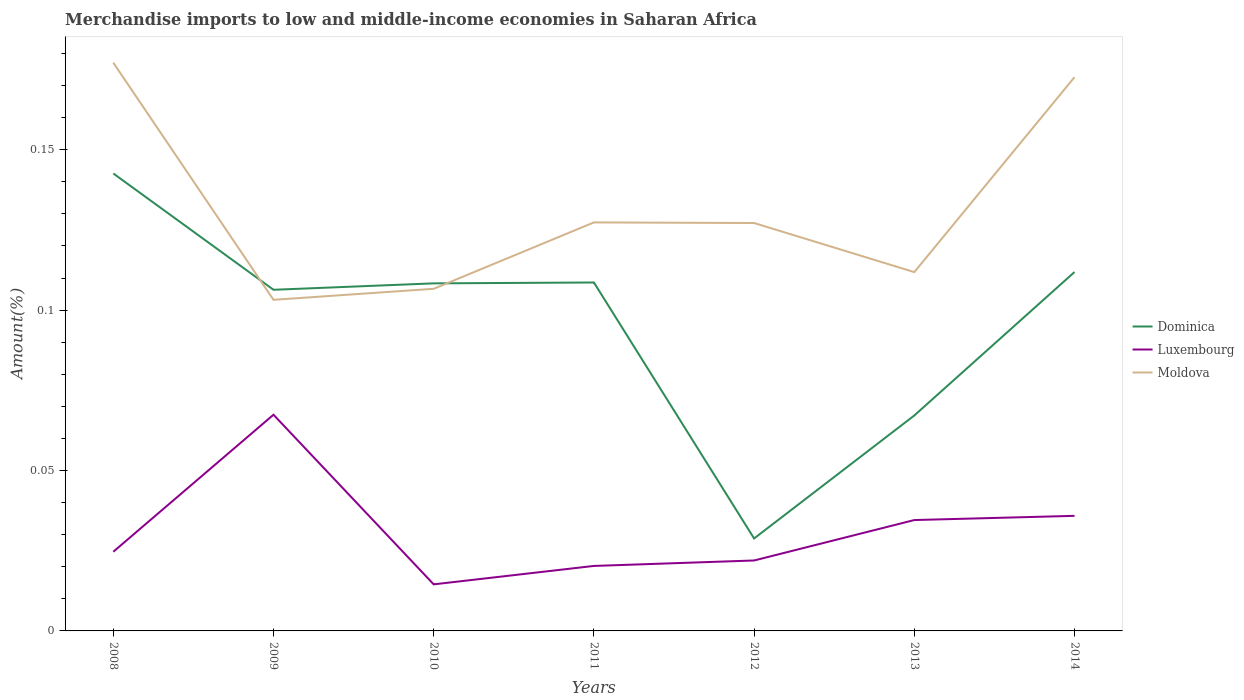How many different coloured lines are there?
Make the answer very short. 3. Across all years, what is the maximum percentage of amount earned from merchandise imports in Luxembourg?
Make the answer very short. 0.01. In which year was the percentage of amount earned from merchandise imports in Moldova maximum?
Your response must be concise. 2009. What is the total percentage of amount earned from merchandise imports in Luxembourg in the graph?
Provide a succinct answer. 0.05. What is the difference between the highest and the second highest percentage of amount earned from merchandise imports in Dominica?
Your answer should be compact. 0.11. What is the difference between the highest and the lowest percentage of amount earned from merchandise imports in Luxembourg?
Offer a terse response. 3. How many years are there in the graph?
Give a very brief answer. 7. Are the values on the major ticks of Y-axis written in scientific E-notation?
Keep it short and to the point. No. Does the graph contain any zero values?
Keep it short and to the point. No. How many legend labels are there?
Your answer should be compact. 3. How are the legend labels stacked?
Provide a succinct answer. Vertical. What is the title of the graph?
Keep it short and to the point. Merchandise imports to low and middle-income economies in Saharan Africa. What is the label or title of the Y-axis?
Offer a very short reply. Amount(%). What is the Amount(%) of Dominica in 2008?
Ensure brevity in your answer.  0.14. What is the Amount(%) in Luxembourg in 2008?
Provide a succinct answer. 0.02. What is the Amount(%) of Moldova in 2008?
Make the answer very short. 0.18. What is the Amount(%) in Dominica in 2009?
Your answer should be very brief. 0.11. What is the Amount(%) in Luxembourg in 2009?
Make the answer very short. 0.07. What is the Amount(%) of Moldova in 2009?
Your answer should be very brief. 0.1. What is the Amount(%) in Dominica in 2010?
Offer a very short reply. 0.11. What is the Amount(%) of Luxembourg in 2010?
Keep it short and to the point. 0.01. What is the Amount(%) in Moldova in 2010?
Your response must be concise. 0.11. What is the Amount(%) in Dominica in 2011?
Your answer should be very brief. 0.11. What is the Amount(%) in Luxembourg in 2011?
Your response must be concise. 0.02. What is the Amount(%) in Moldova in 2011?
Offer a very short reply. 0.13. What is the Amount(%) of Dominica in 2012?
Ensure brevity in your answer.  0.03. What is the Amount(%) in Luxembourg in 2012?
Provide a short and direct response. 0.02. What is the Amount(%) in Moldova in 2012?
Provide a succinct answer. 0.13. What is the Amount(%) of Dominica in 2013?
Your response must be concise. 0.07. What is the Amount(%) of Luxembourg in 2013?
Your answer should be compact. 0.03. What is the Amount(%) in Moldova in 2013?
Offer a terse response. 0.11. What is the Amount(%) of Dominica in 2014?
Provide a short and direct response. 0.11. What is the Amount(%) in Luxembourg in 2014?
Your response must be concise. 0.04. What is the Amount(%) of Moldova in 2014?
Give a very brief answer. 0.17. Across all years, what is the maximum Amount(%) of Dominica?
Your response must be concise. 0.14. Across all years, what is the maximum Amount(%) of Luxembourg?
Keep it short and to the point. 0.07. Across all years, what is the maximum Amount(%) of Moldova?
Provide a succinct answer. 0.18. Across all years, what is the minimum Amount(%) of Dominica?
Offer a terse response. 0.03. Across all years, what is the minimum Amount(%) in Luxembourg?
Offer a very short reply. 0.01. Across all years, what is the minimum Amount(%) in Moldova?
Offer a terse response. 0.1. What is the total Amount(%) of Dominica in the graph?
Give a very brief answer. 0.67. What is the total Amount(%) in Luxembourg in the graph?
Your answer should be compact. 0.22. What is the total Amount(%) of Moldova in the graph?
Offer a terse response. 0.93. What is the difference between the Amount(%) in Dominica in 2008 and that in 2009?
Ensure brevity in your answer.  0.04. What is the difference between the Amount(%) of Luxembourg in 2008 and that in 2009?
Offer a very short reply. -0.04. What is the difference between the Amount(%) in Moldova in 2008 and that in 2009?
Offer a very short reply. 0.07. What is the difference between the Amount(%) of Dominica in 2008 and that in 2010?
Ensure brevity in your answer.  0.03. What is the difference between the Amount(%) in Luxembourg in 2008 and that in 2010?
Provide a short and direct response. 0.01. What is the difference between the Amount(%) of Moldova in 2008 and that in 2010?
Provide a short and direct response. 0.07. What is the difference between the Amount(%) in Dominica in 2008 and that in 2011?
Offer a terse response. 0.03. What is the difference between the Amount(%) of Luxembourg in 2008 and that in 2011?
Offer a very short reply. 0. What is the difference between the Amount(%) of Moldova in 2008 and that in 2011?
Ensure brevity in your answer.  0.05. What is the difference between the Amount(%) of Dominica in 2008 and that in 2012?
Your answer should be compact. 0.11. What is the difference between the Amount(%) of Luxembourg in 2008 and that in 2012?
Give a very brief answer. 0. What is the difference between the Amount(%) in Dominica in 2008 and that in 2013?
Your response must be concise. 0.08. What is the difference between the Amount(%) in Luxembourg in 2008 and that in 2013?
Your answer should be very brief. -0.01. What is the difference between the Amount(%) of Moldova in 2008 and that in 2013?
Give a very brief answer. 0.07. What is the difference between the Amount(%) of Dominica in 2008 and that in 2014?
Give a very brief answer. 0.03. What is the difference between the Amount(%) in Luxembourg in 2008 and that in 2014?
Make the answer very short. -0.01. What is the difference between the Amount(%) in Moldova in 2008 and that in 2014?
Your response must be concise. 0. What is the difference between the Amount(%) of Dominica in 2009 and that in 2010?
Provide a short and direct response. -0. What is the difference between the Amount(%) in Luxembourg in 2009 and that in 2010?
Offer a terse response. 0.05. What is the difference between the Amount(%) of Moldova in 2009 and that in 2010?
Offer a very short reply. -0. What is the difference between the Amount(%) of Dominica in 2009 and that in 2011?
Provide a short and direct response. -0. What is the difference between the Amount(%) in Luxembourg in 2009 and that in 2011?
Ensure brevity in your answer.  0.05. What is the difference between the Amount(%) of Moldova in 2009 and that in 2011?
Provide a short and direct response. -0.02. What is the difference between the Amount(%) in Dominica in 2009 and that in 2012?
Give a very brief answer. 0.08. What is the difference between the Amount(%) of Luxembourg in 2009 and that in 2012?
Ensure brevity in your answer.  0.05. What is the difference between the Amount(%) in Moldova in 2009 and that in 2012?
Ensure brevity in your answer.  -0.02. What is the difference between the Amount(%) of Dominica in 2009 and that in 2013?
Provide a succinct answer. 0.04. What is the difference between the Amount(%) of Luxembourg in 2009 and that in 2013?
Offer a terse response. 0.03. What is the difference between the Amount(%) in Moldova in 2009 and that in 2013?
Make the answer very short. -0.01. What is the difference between the Amount(%) of Dominica in 2009 and that in 2014?
Your response must be concise. -0.01. What is the difference between the Amount(%) of Luxembourg in 2009 and that in 2014?
Provide a succinct answer. 0.03. What is the difference between the Amount(%) in Moldova in 2009 and that in 2014?
Keep it short and to the point. -0.07. What is the difference between the Amount(%) of Dominica in 2010 and that in 2011?
Offer a very short reply. -0. What is the difference between the Amount(%) in Luxembourg in 2010 and that in 2011?
Keep it short and to the point. -0.01. What is the difference between the Amount(%) of Moldova in 2010 and that in 2011?
Your answer should be compact. -0.02. What is the difference between the Amount(%) in Dominica in 2010 and that in 2012?
Your answer should be very brief. 0.08. What is the difference between the Amount(%) of Luxembourg in 2010 and that in 2012?
Ensure brevity in your answer.  -0.01. What is the difference between the Amount(%) of Moldova in 2010 and that in 2012?
Your answer should be very brief. -0.02. What is the difference between the Amount(%) of Dominica in 2010 and that in 2013?
Offer a very short reply. 0.04. What is the difference between the Amount(%) of Luxembourg in 2010 and that in 2013?
Keep it short and to the point. -0.02. What is the difference between the Amount(%) of Moldova in 2010 and that in 2013?
Your response must be concise. -0.01. What is the difference between the Amount(%) in Dominica in 2010 and that in 2014?
Keep it short and to the point. -0. What is the difference between the Amount(%) in Luxembourg in 2010 and that in 2014?
Offer a very short reply. -0.02. What is the difference between the Amount(%) in Moldova in 2010 and that in 2014?
Keep it short and to the point. -0.07. What is the difference between the Amount(%) in Dominica in 2011 and that in 2012?
Keep it short and to the point. 0.08. What is the difference between the Amount(%) in Luxembourg in 2011 and that in 2012?
Provide a short and direct response. -0. What is the difference between the Amount(%) in Moldova in 2011 and that in 2012?
Give a very brief answer. 0. What is the difference between the Amount(%) in Dominica in 2011 and that in 2013?
Your answer should be compact. 0.04. What is the difference between the Amount(%) in Luxembourg in 2011 and that in 2013?
Offer a terse response. -0.01. What is the difference between the Amount(%) of Moldova in 2011 and that in 2013?
Offer a very short reply. 0.02. What is the difference between the Amount(%) of Dominica in 2011 and that in 2014?
Ensure brevity in your answer.  -0. What is the difference between the Amount(%) in Luxembourg in 2011 and that in 2014?
Your answer should be compact. -0.02. What is the difference between the Amount(%) of Moldova in 2011 and that in 2014?
Give a very brief answer. -0.05. What is the difference between the Amount(%) of Dominica in 2012 and that in 2013?
Your answer should be very brief. -0.04. What is the difference between the Amount(%) of Luxembourg in 2012 and that in 2013?
Keep it short and to the point. -0.01. What is the difference between the Amount(%) in Moldova in 2012 and that in 2013?
Your response must be concise. 0.02. What is the difference between the Amount(%) in Dominica in 2012 and that in 2014?
Make the answer very short. -0.08. What is the difference between the Amount(%) of Luxembourg in 2012 and that in 2014?
Ensure brevity in your answer.  -0.01. What is the difference between the Amount(%) of Moldova in 2012 and that in 2014?
Offer a terse response. -0.05. What is the difference between the Amount(%) in Dominica in 2013 and that in 2014?
Make the answer very short. -0.04. What is the difference between the Amount(%) in Luxembourg in 2013 and that in 2014?
Your answer should be very brief. -0. What is the difference between the Amount(%) in Moldova in 2013 and that in 2014?
Offer a terse response. -0.06. What is the difference between the Amount(%) in Dominica in 2008 and the Amount(%) in Luxembourg in 2009?
Ensure brevity in your answer.  0.08. What is the difference between the Amount(%) of Dominica in 2008 and the Amount(%) of Moldova in 2009?
Your response must be concise. 0.04. What is the difference between the Amount(%) in Luxembourg in 2008 and the Amount(%) in Moldova in 2009?
Offer a very short reply. -0.08. What is the difference between the Amount(%) of Dominica in 2008 and the Amount(%) of Luxembourg in 2010?
Provide a succinct answer. 0.13. What is the difference between the Amount(%) in Dominica in 2008 and the Amount(%) in Moldova in 2010?
Ensure brevity in your answer.  0.04. What is the difference between the Amount(%) in Luxembourg in 2008 and the Amount(%) in Moldova in 2010?
Your answer should be compact. -0.08. What is the difference between the Amount(%) in Dominica in 2008 and the Amount(%) in Luxembourg in 2011?
Provide a short and direct response. 0.12. What is the difference between the Amount(%) of Dominica in 2008 and the Amount(%) of Moldova in 2011?
Make the answer very short. 0.02. What is the difference between the Amount(%) in Luxembourg in 2008 and the Amount(%) in Moldova in 2011?
Offer a terse response. -0.1. What is the difference between the Amount(%) of Dominica in 2008 and the Amount(%) of Luxembourg in 2012?
Provide a succinct answer. 0.12. What is the difference between the Amount(%) in Dominica in 2008 and the Amount(%) in Moldova in 2012?
Offer a very short reply. 0.02. What is the difference between the Amount(%) in Luxembourg in 2008 and the Amount(%) in Moldova in 2012?
Make the answer very short. -0.1. What is the difference between the Amount(%) in Dominica in 2008 and the Amount(%) in Luxembourg in 2013?
Give a very brief answer. 0.11. What is the difference between the Amount(%) of Dominica in 2008 and the Amount(%) of Moldova in 2013?
Give a very brief answer. 0.03. What is the difference between the Amount(%) of Luxembourg in 2008 and the Amount(%) of Moldova in 2013?
Keep it short and to the point. -0.09. What is the difference between the Amount(%) in Dominica in 2008 and the Amount(%) in Luxembourg in 2014?
Make the answer very short. 0.11. What is the difference between the Amount(%) in Dominica in 2008 and the Amount(%) in Moldova in 2014?
Ensure brevity in your answer.  -0.03. What is the difference between the Amount(%) of Luxembourg in 2008 and the Amount(%) of Moldova in 2014?
Provide a succinct answer. -0.15. What is the difference between the Amount(%) of Dominica in 2009 and the Amount(%) of Luxembourg in 2010?
Make the answer very short. 0.09. What is the difference between the Amount(%) of Dominica in 2009 and the Amount(%) of Moldova in 2010?
Give a very brief answer. -0. What is the difference between the Amount(%) in Luxembourg in 2009 and the Amount(%) in Moldova in 2010?
Your answer should be very brief. -0.04. What is the difference between the Amount(%) in Dominica in 2009 and the Amount(%) in Luxembourg in 2011?
Make the answer very short. 0.09. What is the difference between the Amount(%) in Dominica in 2009 and the Amount(%) in Moldova in 2011?
Ensure brevity in your answer.  -0.02. What is the difference between the Amount(%) of Luxembourg in 2009 and the Amount(%) of Moldova in 2011?
Provide a short and direct response. -0.06. What is the difference between the Amount(%) in Dominica in 2009 and the Amount(%) in Luxembourg in 2012?
Make the answer very short. 0.08. What is the difference between the Amount(%) in Dominica in 2009 and the Amount(%) in Moldova in 2012?
Offer a very short reply. -0.02. What is the difference between the Amount(%) in Luxembourg in 2009 and the Amount(%) in Moldova in 2012?
Make the answer very short. -0.06. What is the difference between the Amount(%) of Dominica in 2009 and the Amount(%) of Luxembourg in 2013?
Offer a terse response. 0.07. What is the difference between the Amount(%) in Dominica in 2009 and the Amount(%) in Moldova in 2013?
Make the answer very short. -0.01. What is the difference between the Amount(%) of Luxembourg in 2009 and the Amount(%) of Moldova in 2013?
Make the answer very short. -0.04. What is the difference between the Amount(%) in Dominica in 2009 and the Amount(%) in Luxembourg in 2014?
Make the answer very short. 0.07. What is the difference between the Amount(%) of Dominica in 2009 and the Amount(%) of Moldova in 2014?
Provide a short and direct response. -0.07. What is the difference between the Amount(%) in Luxembourg in 2009 and the Amount(%) in Moldova in 2014?
Provide a succinct answer. -0.11. What is the difference between the Amount(%) of Dominica in 2010 and the Amount(%) of Luxembourg in 2011?
Your answer should be very brief. 0.09. What is the difference between the Amount(%) of Dominica in 2010 and the Amount(%) of Moldova in 2011?
Your answer should be compact. -0.02. What is the difference between the Amount(%) of Luxembourg in 2010 and the Amount(%) of Moldova in 2011?
Offer a very short reply. -0.11. What is the difference between the Amount(%) of Dominica in 2010 and the Amount(%) of Luxembourg in 2012?
Offer a very short reply. 0.09. What is the difference between the Amount(%) of Dominica in 2010 and the Amount(%) of Moldova in 2012?
Give a very brief answer. -0.02. What is the difference between the Amount(%) of Luxembourg in 2010 and the Amount(%) of Moldova in 2012?
Your answer should be very brief. -0.11. What is the difference between the Amount(%) of Dominica in 2010 and the Amount(%) of Luxembourg in 2013?
Offer a very short reply. 0.07. What is the difference between the Amount(%) in Dominica in 2010 and the Amount(%) in Moldova in 2013?
Offer a very short reply. -0. What is the difference between the Amount(%) in Luxembourg in 2010 and the Amount(%) in Moldova in 2013?
Provide a short and direct response. -0.1. What is the difference between the Amount(%) in Dominica in 2010 and the Amount(%) in Luxembourg in 2014?
Ensure brevity in your answer.  0.07. What is the difference between the Amount(%) of Dominica in 2010 and the Amount(%) of Moldova in 2014?
Make the answer very short. -0.06. What is the difference between the Amount(%) of Luxembourg in 2010 and the Amount(%) of Moldova in 2014?
Give a very brief answer. -0.16. What is the difference between the Amount(%) in Dominica in 2011 and the Amount(%) in Luxembourg in 2012?
Your response must be concise. 0.09. What is the difference between the Amount(%) of Dominica in 2011 and the Amount(%) of Moldova in 2012?
Make the answer very short. -0.02. What is the difference between the Amount(%) in Luxembourg in 2011 and the Amount(%) in Moldova in 2012?
Offer a very short reply. -0.11. What is the difference between the Amount(%) in Dominica in 2011 and the Amount(%) in Luxembourg in 2013?
Give a very brief answer. 0.07. What is the difference between the Amount(%) of Dominica in 2011 and the Amount(%) of Moldova in 2013?
Your answer should be compact. -0. What is the difference between the Amount(%) in Luxembourg in 2011 and the Amount(%) in Moldova in 2013?
Your answer should be very brief. -0.09. What is the difference between the Amount(%) in Dominica in 2011 and the Amount(%) in Luxembourg in 2014?
Give a very brief answer. 0.07. What is the difference between the Amount(%) of Dominica in 2011 and the Amount(%) of Moldova in 2014?
Keep it short and to the point. -0.06. What is the difference between the Amount(%) in Luxembourg in 2011 and the Amount(%) in Moldova in 2014?
Offer a terse response. -0.15. What is the difference between the Amount(%) in Dominica in 2012 and the Amount(%) in Luxembourg in 2013?
Ensure brevity in your answer.  -0.01. What is the difference between the Amount(%) of Dominica in 2012 and the Amount(%) of Moldova in 2013?
Offer a terse response. -0.08. What is the difference between the Amount(%) in Luxembourg in 2012 and the Amount(%) in Moldova in 2013?
Provide a succinct answer. -0.09. What is the difference between the Amount(%) in Dominica in 2012 and the Amount(%) in Luxembourg in 2014?
Give a very brief answer. -0.01. What is the difference between the Amount(%) in Dominica in 2012 and the Amount(%) in Moldova in 2014?
Your answer should be very brief. -0.14. What is the difference between the Amount(%) in Luxembourg in 2012 and the Amount(%) in Moldova in 2014?
Make the answer very short. -0.15. What is the difference between the Amount(%) of Dominica in 2013 and the Amount(%) of Luxembourg in 2014?
Keep it short and to the point. 0.03. What is the difference between the Amount(%) of Dominica in 2013 and the Amount(%) of Moldova in 2014?
Give a very brief answer. -0.11. What is the difference between the Amount(%) in Luxembourg in 2013 and the Amount(%) in Moldova in 2014?
Provide a short and direct response. -0.14. What is the average Amount(%) in Dominica per year?
Give a very brief answer. 0.1. What is the average Amount(%) in Luxembourg per year?
Your answer should be very brief. 0.03. What is the average Amount(%) of Moldova per year?
Offer a very short reply. 0.13. In the year 2008, what is the difference between the Amount(%) of Dominica and Amount(%) of Luxembourg?
Your response must be concise. 0.12. In the year 2008, what is the difference between the Amount(%) in Dominica and Amount(%) in Moldova?
Provide a short and direct response. -0.03. In the year 2008, what is the difference between the Amount(%) in Luxembourg and Amount(%) in Moldova?
Provide a succinct answer. -0.15. In the year 2009, what is the difference between the Amount(%) of Dominica and Amount(%) of Luxembourg?
Provide a short and direct response. 0.04. In the year 2009, what is the difference between the Amount(%) in Dominica and Amount(%) in Moldova?
Ensure brevity in your answer.  0. In the year 2009, what is the difference between the Amount(%) in Luxembourg and Amount(%) in Moldova?
Your response must be concise. -0.04. In the year 2010, what is the difference between the Amount(%) of Dominica and Amount(%) of Luxembourg?
Ensure brevity in your answer.  0.09. In the year 2010, what is the difference between the Amount(%) of Dominica and Amount(%) of Moldova?
Provide a succinct answer. 0. In the year 2010, what is the difference between the Amount(%) in Luxembourg and Amount(%) in Moldova?
Your answer should be very brief. -0.09. In the year 2011, what is the difference between the Amount(%) in Dominica and Amount(%) in Luxembourg?
Offer a terse response. 0.09. In the year 2011, what is the difference between the Amount(%) in Dominica and Amount(%) in Moldova?
Offer a terse response. -0.02. In the year 2011, what is the difference between the Amount(%) of Luxembourg and Amount(%) of Moldova?
Keep it short and to the point. -0.11. In the year 2012, what is the difference between the Amount(%) in Dominica and Amount(%) in Luxembourg?
Offer a terse response. 0.01. In the year 2012, what is the difference between the Amount(%) of Dominica and Amount(%) of Moldova?
Offer a terse response. -0.1. In the year 2012, what is the difference between the Amount(%) of Luxembourg and Amount(%) of Moldova?
Ensure brevity in your answer.  -0.11. In the year 2013, what is the difference between the Amount(%) of Dominica and Amount(%) of Luxembourg?
Your answer should be very brief. 0.03. In the year 2013, what is the difference between the Amount(%) of Dominica and Amount(%) of Moldova?
Provide a short and direct response. -0.04. In the year 2013, what is the difference between the Amount(%) of Luxembourg and Amount(%) of Moldova?
Your answer should be compact. -0.08. In the year 2014, what is the difference between the Amount(%) of Dominica and Amount(%) of Luxembourg?
Offer a very short reply. 0.08. In the year 2014, what is the difference between the Amount(%) of Dominica and Amount(%) of Moldova?
Offer a terse response. -0.06. In the year 2014, what is the difference between the Amount(%) of Luxembourg and Amount(%) of Moldova?
Offer a terse response. -0.14. What is the ratio of the Amount(%) in Dominica in 2008 to that in 2009?
Offer a very short reply. 1.34. What is the ratio of the Amount(%) of Luxembourg in 2008 to that in 2009?
Provide a short and direct response. 0.37. What is the ratio of the Amount(%) in Moldova in 2008 to that in 2009?
Offer a terse response. 1.72. What is the ratio of the Amount(%) in Dominica in 2008 to that in 2010?
Give a very brief answer. 1.32. What is the ratio of the Amount(%) in Luxembourg in 2008 to that in 2010?
Keep it short and to the point. 1.7. What is the ratio of the Amount(%) of Moldova in 2008 to that in 2010?
Keep it short and to the point. 1.66. What is the ratio of the Amount(%) of Dominica in 2008 to that in 2011?
Offer a very short reply. 1.31. What is the ratio of the Amount(%) of Luxembourg in 2008 to that in 2011?
Provide a succinct answer. 1.22. What is the ratio of the Amount(%) of Moldova in 2008 to that in 2011?
Your answer should be very brief. 1.39. What is the ratio of the Amount(%) of Dominica in 2008 to that in 2012?
Your response must be concise. 4.95. What is the ratio of the Amount(%) of Luxembourg in 2008 to that in 2012?
Provide a short and direct response. 1.12. What is the ratio of the Amount(%) in Moldova in 2008 to that in 2012?
Ensure brevity in your answer.  1.39. What is the ratio of the Amount(%) of Dominica in 2008 to that in 2013?
Your answer should be compact. 2.12. What is the ratio of the Amount(%) in Luxembourg in 2008 to that in 2013?
Offer a terse response. 0.71. What is the ratio of the Amount(%) in Moldova in 2008 to that in 2013?
Make the answer very short. 1.58. What is the ratio of the Amount(%) in Dominica in 2008 to that in 2014?
Provide a short and direct response. 1.27. What is the ratio of the Amount(%) of Luxembourg in 2008 to that in 2014?
Offer a very short reply. 0.69. What is the ratio of the Amount(%) in Moldova in 2008 to that in 2014?
Offer a terse response. 1.03. What is the ratio of the Amount(%) of Dominica in 2009 to that in 2010?
Give a very brief answer. 0.98. What is the ratio of the Amount(%) of Luxembourg in 2009 to that in 2010?
Keep it short and to the point. 4.64. What is the ratio of the Amount(%) of Moldova in 2009 to that in 2010?
Keep it short and to the point. 0.97. What is the ratio of the Amount(%) in Dominica in 2009 to that in 2011?
Your response must be concise. 0.98. What is the ratio of the Amount(%) of Luxembourg in 2009 to that in 2011?
Offer a very short reply. 3.33. What is the ratio of the Amount(%) in Moldova in 2009 to that in 2011?
Offer a very short reply. 0.81. What is the ratio of the Amount(%) of Dominica in 2009 to that in 2012?
Your answer should be compact. 3.69. What is the ratio of the Amount(%) of Luxembourg in 2009 to that in 2012?
Your answer should be very brief. 3.07. What is the ratio of the Amount(%) of Moldova in 2009 to that in 2012?
Offer a very short reply. 0.81. What is the ratio of the Amount(%) in Dominica in 2009 to that in 2013?
Your answer should be very brief. 1.58. What is the ratio of the Amount(%) in Luxembourg in 2009 to that in 2013?
Make the answer very short. 1.95. What is the ratio of the Amount(%) of Moldova in 2009 to that in 2013?
Provide a short and direct response. 0.92. What is the ratio of the Amount(%) in Dominica in 2009 to that in 2014?
Provide a short and direct response. 0.95. What is the ratio of the Amount(%) in Luxembourg in 2009 to that in 2014?
Give a very brief answer. 1.88. What is the ratio of the Amount(%) in Moldova in 2009 to that in 2014?
Give a very brief answer. 0.6. What is the ratio of the Amount(%) of Dominica in 2010 to that in 2011?
Your answer should be very brief. 1. What is the ratio of the Amount(%) in Luxembourg in 2010 to that in 2011?
Provide a succinct answer. 0.72. What is the ratio of the Amount(%) of Moldova in 2010 to that in 2011?
Keep it short and to the point. 0.84. What is the ratio of the Amount(%) in Dominica in 2010 to that in 2012?
Keep it short and to the point. 3.76. What is the ratio of the Amount(%) of Luxembourg in 2010 to that in 2012?
Provide a succinct answer. 0.66. What is the ratio of the Amount(%) in Moldova in 2010 to that in 2012?
Keep it short and to the point. 0.84. What is the ratio of the Amount(%) in Dominica in 2010 to that in 2013?
Ensure brevity in your answer.  1.61. What is the ratio of the Amount(%) of Luxembourg in 2010 to that in 2013?
Your answer should be compact. 0.42. What is the ratio of the Amount(%) in Moldova in 2010 to that in 2013?
Keep it short and to the point. 0.95. What is the ratio of the Amount(%) of Dominica in 2010 to that in 2014?
Offer a very short reply. 0.97. What is the ratio of the Amount(%) in Luxembourg in 2010 to that in 2014?
Provide a succinct answer. 0.4. What is the ratio of the Amount(%) in Moldova in 2010 to that in 2014?
Provide a succinct answer. 0.62. What is the ratio of the Amount(%) of Dominica in 2011 to that in 2012?
Keep it short and to the point. 3.77. What is the ratio of the Amount(%) in Luxembourg in 2011 to that in 2012?
Your answer should be very brief. 0.92. What is the ratio of the Amount(%) in Moldova in 2011 to that in 2012?
Your answer should be very brief. 1. What is the ratio of the Amount(%) in Dominica in 2011 to that in 2013?
Provide a succinct answer. 1.62. What is the ratio of the Amount(%) of Luxembourg in 2011 to that in 2013?
Make the answer very short. 0.59. What is the ratio of the Amount(%) of Moldova in 2011 to that in 2013?
Keep it short and to the point. 1.14. What is the ratio of the Amount(%) in Dominica in 2011 to that in 2014?
Provide a short and direct response. 0.97. What is the ratio of the Amount(%) of Luxembourg in 2011 to that in 2014?
Keep it short and to the point. 0.56. What is the ratio of the Amount(%) of Moldova in 2011 to that in 2014?
Provide a succinct answer. 0.74. What is the ratio of the Amount(%) of Dominica in 2012 to that in 2013?
Ensure brevity in your answer.  0.43. What is the ratio of the Amount(%) of Luxembourg in 2012 to that in 2013?
Offer a very short reply. 0.64. What is the ratio of the Amount(%) in Moldova in 2012 to that in 2013?
Keep it short and to the point. 1.14. What is the ratio of the Amount(%) of Dominica in 2012 to that in 2014?
Ensure brevity in your answer.  0.26. What is the ratio of the Amount(%) of Luxembourg in 2012 to that in 2014?
Make the answer very short. 0.61. What is the ratio of the Amount(%) in Moldova in 2012 to that in 2014?
Your response must be concise. 0.74. What is the ratio of the Amount(%) in Dominica in 2013 to that in 2014?
Offer a very short reply. 0.6. What is the ratio of the Amount(%) of Luxembourg in 2013 to that in 2014?
Provide a short and direct response. 0.96. What is the ratio of the Amount(%) in Moldova in 2013 to that in 2014?
Provide a succinct answer. 0.65. What is the difference between the highest and the second highest Amount(%) in Dominica?
Your answer should be very brief. 0.03. What is the difference between the highest and the second highest Amount(%) of Luxembourg?
Ensure brevity in your answer.  0.03. What is the difference between the highest and the second highest Amount(%) in Moldova?
Keep it short and to the point. 0. What is the difference between the highest and the lowest Amount(%) of Dominica?
Ensure brevity in your answer.  0.11. What is the difference between the highest and the lowest Amount(%) in Luxembourg?
Your answer should be compact. 0.05. What is the difference between the highest and the lowest Amount(%) of Moldova?
Offer a very short reply. 0.07. 